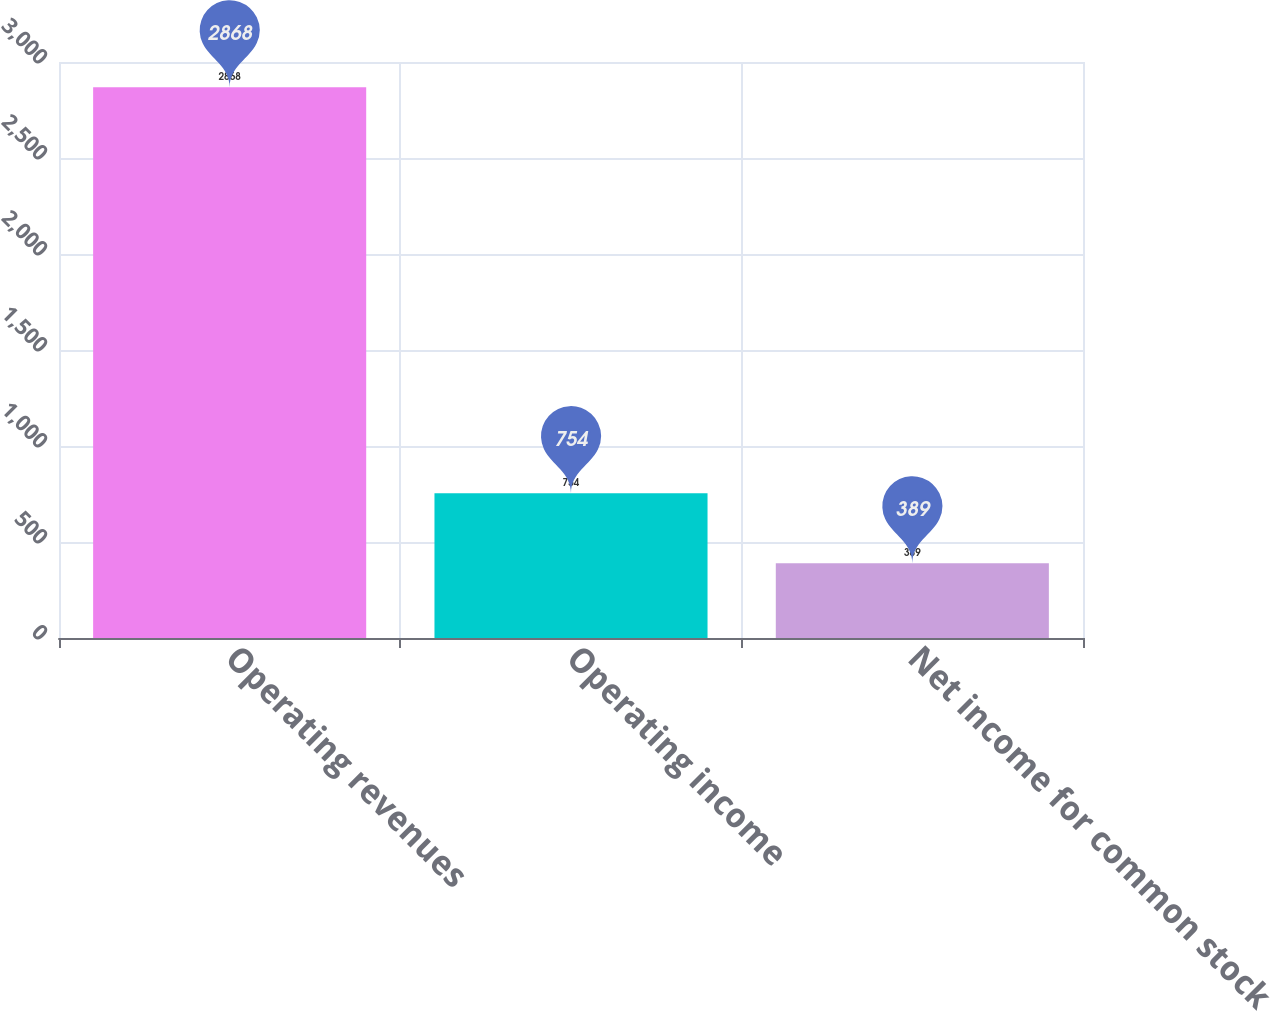Convert chart to OTSL. <chart><loc_0><loc_0><loc_500><loc_500><bar_chart><fcel>Operating revenues<fcel>Operating income<fcel>Net income for common stock<nl><fcel>2868<fcel>754<fcel>389<nl></chart> 